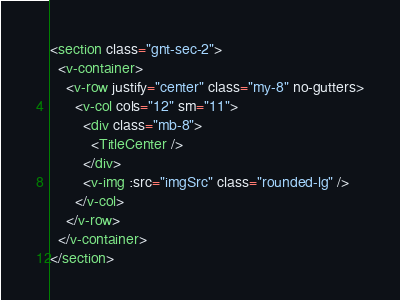Convert code to text. <code><loc_0><loc_0><loc_500><loc_500><_HTML_><section class="gnt-sec-2">
  <v-container>
    <v-row justify="center" class="my-8" no-gutters>
      <v-col cols="12" sm="11">
        <div class="mb-8">
          <TitleCenter />
        </div>
        <v-img :src="imgSrc" class="rounded-lg" />
      </v-col>
    </v-row>
  </v-container>
</section>
</code> 